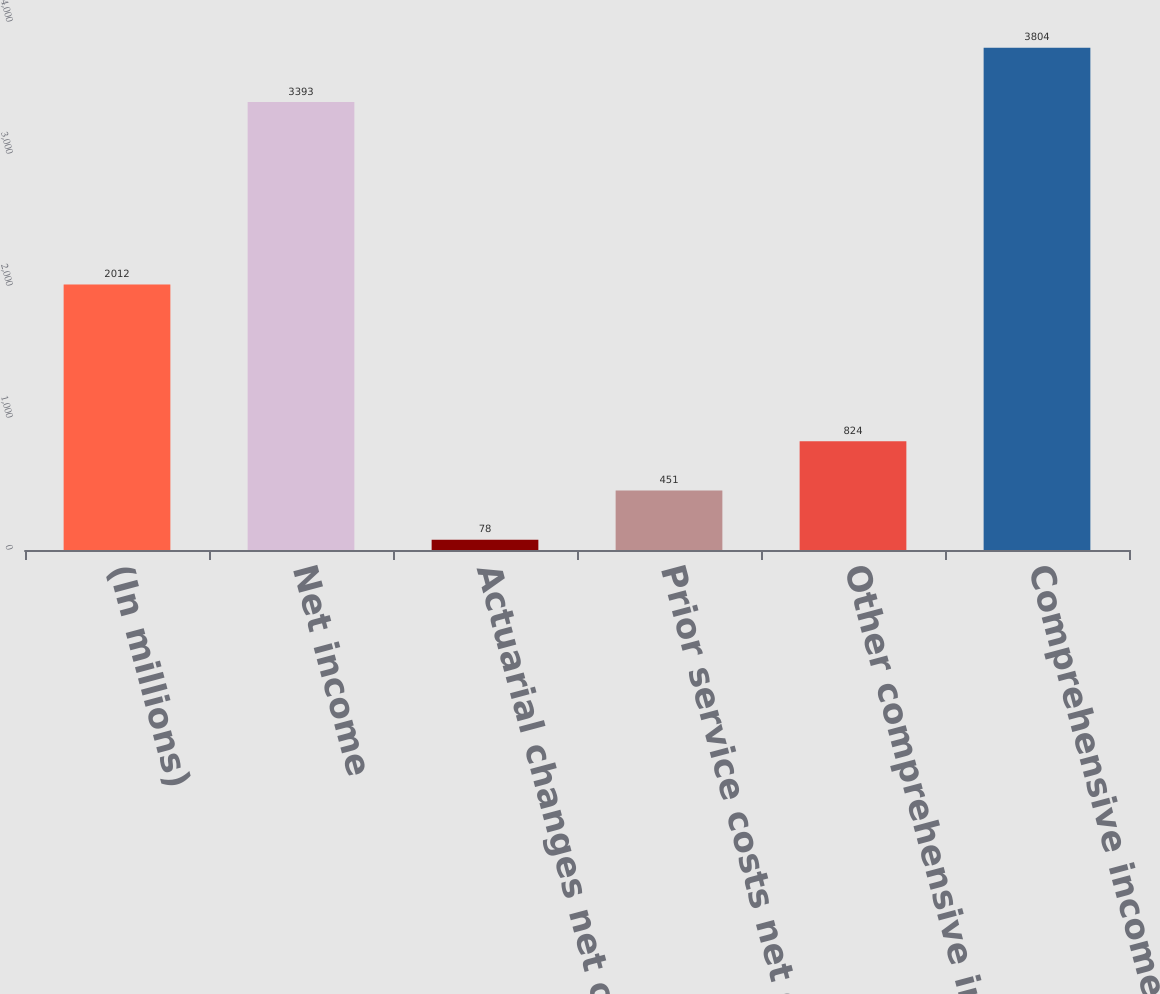<chart> <loc_0><loc_0><loc_500><loc_500><bar_chart><fcel>(In millions)<fcel>Net income<fcel>Actuarial changes net of tax<fcel>Prior service costs net of tax<fcel>Other comprehensive income<fcel>Comprehensive income<nl><fcel>2012<fcel>3393<fcel>78<fcel>451<fcel>824<fcel>3804<nl></chart> 